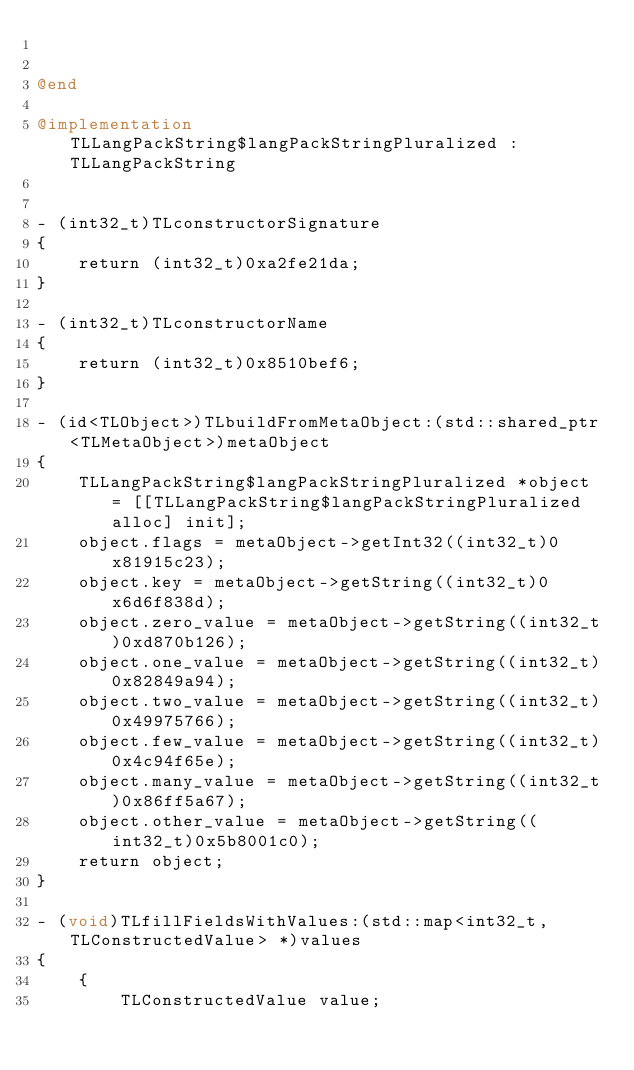<code> <loc_0><loc_0><loc_500><loc_500><_ObjectiveC_>

@end

@implementation TLLangPackString$langPackStringPluralized : TLLangPackString


- (int32_t)TLconstructorSignature
{
    return (int32_t)0xa2fe21da;
}

- (int32_t)TLconstructorName
{
    return (int32_t)0x8510bef6;
}

- (id<TLObject>)TLbuildFromMetaObject:(std::shared_ptr<TLMetaObject>)metaObject
{
    TLLangPackString$langPackStringPluralized *object = [[TLLangPackString$langPackStringPluralized alloc] init];
    object.flags = metaObject->getInt32((int32_t)0x81915c23);
    object.key = metaObject->getString((int32_t)0x6d6f838d);
    object.zero_value = metaObject->getString((int32_t)0xd870b126);
    object.one_value = metaObject->getString((int32_t)0x82849a94);
    object.two_value = metaObject->getString((int32_t)0x49975766);
    object.few_value = metaObject->getString((int32_t)0x4c94f65e);
    object.many_value = metaObject->getString((int32_t)0x86ff5a67);
    object.other_value = metaObject->getString((int32_t)0x5b8001c0);
    return object;
}

- (void)TLfillFieldsWithValues:(std::map<int32_t, TLConstructedValue> *)values
{
    {
        TLConstructedValue value;</code> 